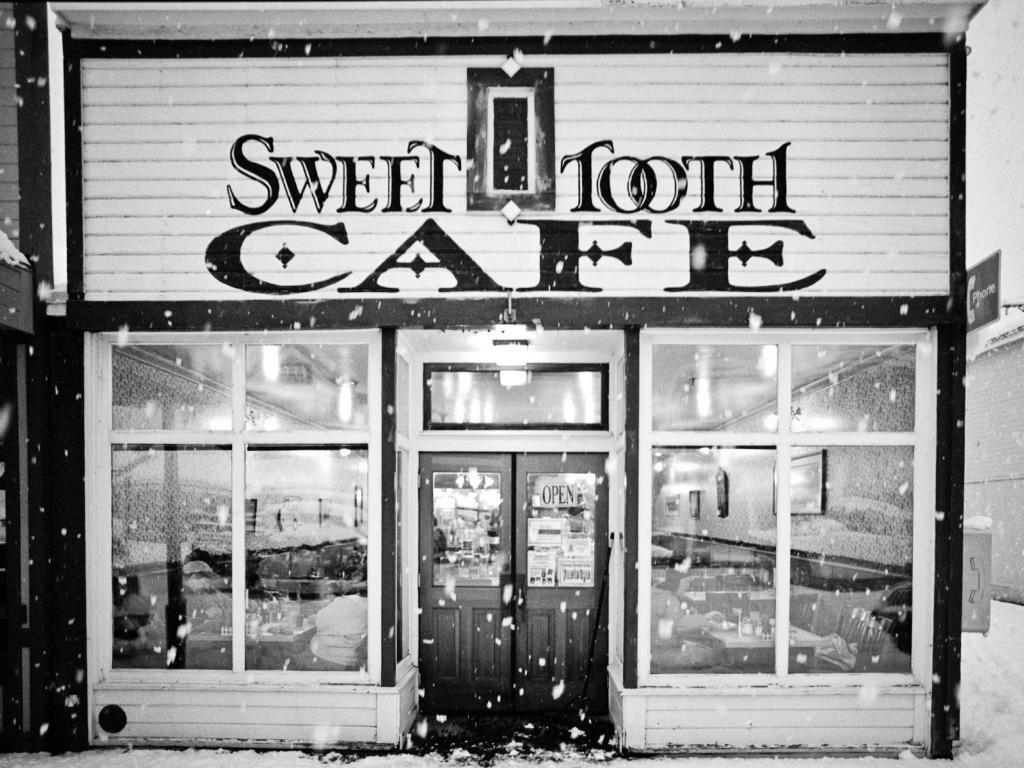In one or two sentences, can you explain what this image depicts? In this image there is a store. in the center there is a door and we can see windows and there is snow. 